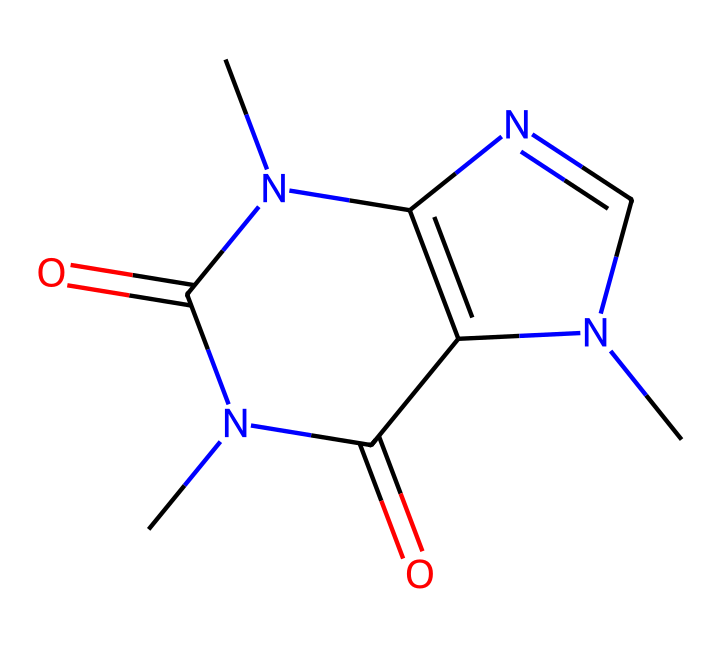What is the molecular formula of caffeine? The SMILES representation can be analyzed to count the elements present. In the representation, we can see: Carbon (C), Nitrogen (N), and Oxygen (O). Counting the atoms, we find 8 Carbon atoms, 10 Hydrogen atoms, 4 Nitrogen atoms, and 2 Oxygen atoms. Thus, the molecular formula is C8H10N4O2.
Answer: C8H10N4O2 How many nitrogen atoms are in the structure? By examining the SMILES representation, we can identify the nitrogen atoms represented by the letter "N." Counting these reveals there are 4 nitrogen atoms present in the structure.
Answer: 4 Is caffeine classified as a pyrimidine derivative? The structure of caffeine includes a fused ring system that has a pyrimidine base. A pyrimidine is a six-membered ring containing two nitrogen atoms at positions one and three. Since caffeine shares this characteristic, it can be classified as a pyrimidine derivative.
Answer: Yes What functional groups are present in caffeine? By analyzing the chemical structure, we can identify functional groups. The SMILES representation indicates the presence of carbonyl groups (C=O) and an amine group (N) due to the nitrogen atoms' connections, specifically looking for the distinct carbonyl functionalities in the structure. Both are characteristic of alkaloids.
Answer: Carbonyl, Amine What type of bonding is primarily found between the atoms in caffeine? Upon reviewing the SMILES representation and analyzing the bonds between atoms, we see that the majority are covalent bonds, which are formed between the carbon, nitrogen, and oxygen atoms in the structure. These are typical in organic molecules.
Answer: Covalent How does the structure of caffeine contribute to its stimulating effects? The structure of caffeine includes methyl groups attached to nitrogen atoms, which affect its activity within the brain's adenosine receptors. The fused ring system also enhances its ability to cross the blood-brain barrier, allowing it to act as a stimulant. This combination of structural features underlies caffeine's stimulating effects.
Answer: Methyl groups, Fused ring What is the total number of rings present in the caffeine structure? By observing the molecular structure represented in the SMILES notation, there are two distinct fusion rings present in caffeine. The specific arrangement of the atoms indicates both are incorporated into the overall structure. Thus, the total rings that can be identified is two.
Answer: 2 